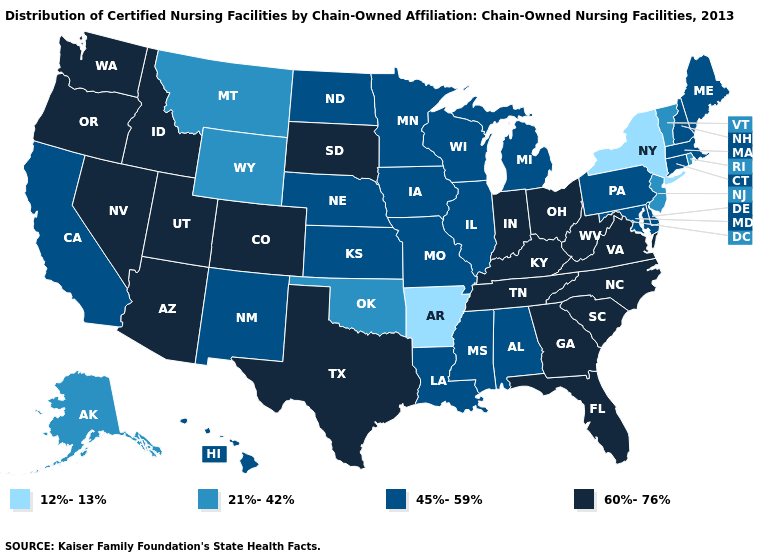What is the highest value in states that border Nevada?
Quick response, please. 60%-76%. Among the states that border Illinois , which have the highest value?
Quick response, please. Indiana, Kentucky. Among the states that border Delaware , does Maryland have the lowest value?
Short answer required. No. What is the lowest value in states that border Texas?
Keep it brief. 12%-13%. What is the value of Alabama?
Give a very brief answer. 45%-59%. Is the legend a continuous bar?
Be succinct. No. Does the map have missing data?
Concise answer only. No. Is the legend a continuous bar?
Concise answer only. No. Among the states that border Texas , does Arkansas have the highest value?
Keep it brief. No. What is the lowest value in states that border Kansas?
Be succinct. 21%-42%. Name the states that have a value in the range 21%-42%?
Be succinct. Alaska, Montana, New Jersey, Oklahoma, Rhode Island, Vermont, Wyoming. Name the states that have a value in the range 45%-59%?
Answer briefly. Alabama, California, Connecticut, Delaware, Hawaii, Illinois, Iowa, Kansas, Louisiana, Maine, Maryland, Massachusetts, Michigan, Minnesota, Mississippi, Missouri, Nebraska, New Hampshire, New Mexico, North Dakota, Pennsylvania, Wisconsin. Does Virginia have the highest value in the USA?
Short answer required. Yes. Does New York have the lowest value in the USA?
Quick response, please. Yes. 